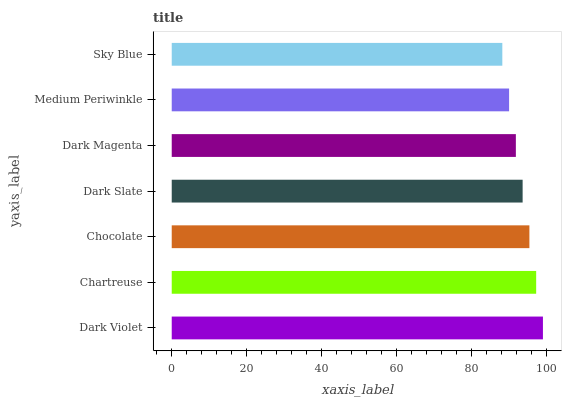Is Sky Blue the minimum?
Answer yes or no. Yes. Is Dark Violet the maximum?
Answer yes or no. Yes. Is Chartreuse the minimum?
Answer yes or no. No. Is Chartreuse the maximum?
Answer yes or no. No. Is Dark Violet greater than Chartreuse?
Answer yes or no. Yes. Is Chartreuse less than Dark Violet?
Answer yes or no. Yes. Is Chartreuse greater than Dark Violet?
Answer yes or no. No. Is Dark Violet less than Chartreuse?
Answer yes or no. No. Is Dark Slate the high median?
Answer yes or no. Yes. Is Dark Slate the low median?
Answer yes or no. Yes. Is Dark Violet the high median?
Answer yes or no. No. Is Medium Periwinkle the low median?
Answer yes or no. No. 